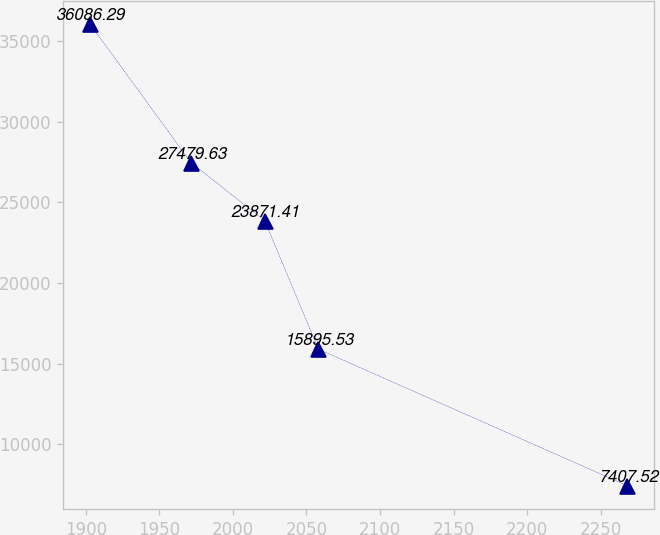Convert chart. <chart><loc_0><loc_0><loc_500><loc_500><line_chart><ecel><fcel>Unnamed: 1<nl><fcel>1902.83<fcel>36086.3<nl><fcel>1971.51<fcel>27479.6<nl><fcel>2021.64<fcel>23871.4<nl><fcel>2058.18<fcel>15895.5<nl><fcel>2268.28<fcel>7407.52<nl></chart> 